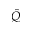Convert formula to latex. <formula><loc_0><loc_0><loc_500><loc_500>\hat { Q }</formula> 